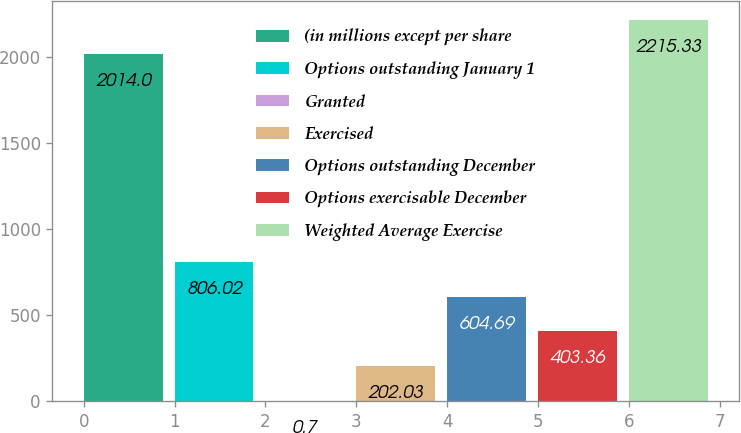<chart> <loc_0><loc_0><loc_500><loc_500><bar_chart><fcel>(in millions except per share<fcel>Options outstanding January 1<fcel>Granted<fcel>Exercised<fcel>Options outstanding December<fcel>Options exercisable December<fcel>Weighted Average Exercise<nl><fcel>2014<fcel>806.02<fcel>0.7<fcel>202.03<fcel>604.69<fcel>403.36<fcel>2215.33<nl></chart> 